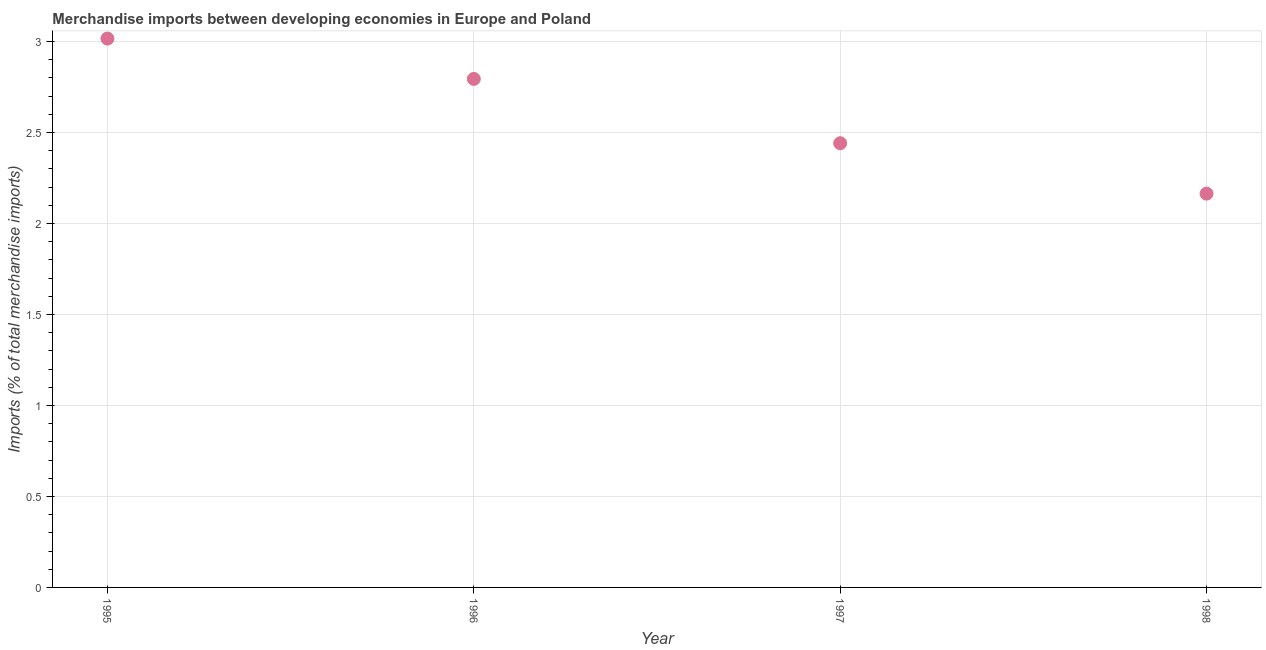What is the merchandise imports in 1997?
Give a very brief answer. 2.44. Across all years, what is the maximum merchandise imports?
Give a very brief answer. 3.02. Across all years, what is the minimum merchandise imports?
Provide a succinct answer. 2.16. In which year was the merchandise imports minimum?
Offer a terse response. 1998. What is the sum of the merchandise imports?
Offer a very short reply. 10.42. What is the difference between the merchandise imports in 1995 and 1996?
Your answer should be compact. 0.22. What is the average merchandise imports per year?
Give a very brief answer. 2.6. What is the median merchandise imports?
Make the answer very short. 2.62. What is the ratio of the merchandise imports in 1997 to that in 1998?
Your answer should be very brief. 1.13. Is the merchandise imports in 1995 less than that in 1996?
Offer a very short reply. No. Is the difference between the merchandise imports in 1995 and 1998 greater than the difference between any two years?
Give a very brief answer. Yes. What is the difference between the highest and the second highest merchandise imports?
Offer a terse response. 0.22. What is the difference between the highest and the lowest merchandise imports?
Your answer should be compact. 0.85. In how many years, is the merchandise imports greater than the average merchandise imports taken over all years?
Your answer should be very brief. 2. How many dotlines are there?
Your answer should be very brief. 1. Are the values on the major ticks of Y-axis written in scientific E-notation?
Your response must be concise. No. Does the graph contain any zero values?
Provide a short and direct response. No. What is the title of the graph?
Provide a short and direct response. Merchandise imports between developing economies in Europe and Poland. What is the label or title of the Y-axis?
Offer a terse response. Imports (% of total merchandise imports). What is the Imports (% of total merchandise imports) in 1995?
Give a very brief answer. 3.02. What is the Imports (% of total merchandise imports) in 1996?
Your response must be concise. 2.79. What is the Imports (% of total merchandise imports) in 1997?
Make the answer very short. 2.44. What is the Imports (% of total merchandise imports) in 1998?
Offer a terse response. 2.16. What is the difference between the Imports (% of total merchandise imports) in 1995 and 1996?
Give a very brief answer. 0.22. What is the difference between the Imports (% of total merchandise imports) in 1995 and 1997?
Your answer should be very brief. 0.58. What is the difference between the Imports (% of total merchandise imports) in 1995 and 1998?
Your answer should be compact. 0.85. What is the difference between the Imports (% of total merchandise imports) in 1996 and 1997?
Offer a very short reply. 0.35. What is the difference between the Imports (% of total merchandise imports) in 1996 and 1998?
Provide a short and direct response. 0.63. What is the difference between the Imports (% of total merchandise imports) in 1997 and 1998?
Ensure brevity in your answer.  0.28. What is the ratio of the Imports (% of total merchandise imports) in 1995 to that in 1996?
Offer a very short reply. 1.08. What is the ratio of the Imports (% of total merchandise imports) in 1995 to that in 1997?
Provide a succinct answer. 1.24. What is the ratio of the Imports (% of total merchandise imports) in 1995 to that in 1998?
Provide a short and direct response. 1.39. What is the ratio of the Imports (% of total merchandise imports) in 1996 to that in 1997?
Provide a succinct answer. 1.15. What is the ratio of the Imports (% of total merchandise imports) in 1996 to that in 1998?
Your response must be concise. 1.29. What is the ratio of the Imports (% of total merchandise imports) in 1997 to that in 1998?
Keep it short and to the point. 1.13. 